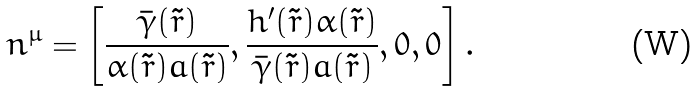Convert formula to latex. <formula><loc_0><loc_0><loc_500><loc_500>n ^ { \mu } = \left [ \frac { \bar { \gamma } ( \tilde { r } ) } { \alpha ( \tilde { r } ) a ( \tilde { r } ) } , \frac { h ^ { \prime } ( \tilde { r } ) \alpha ( \tilde { r } ) } { \bar { \gamma } ( \tilde { r } ) a ( \tilde { r } ) } , 0 , 0 \right ] .</formula> 